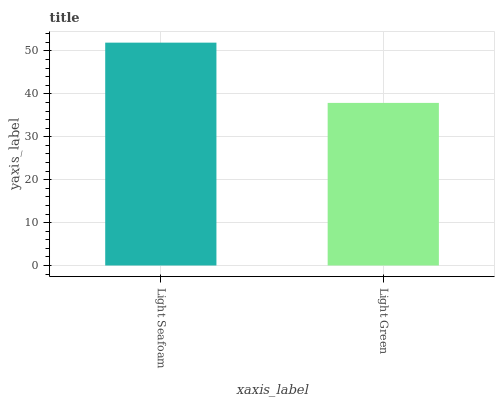Is Light Green the maximum?
Answer yes or no. No. Is Light Seafoam greater than Light Green?
Answer yes or no. Yes. Is Light Green less than Light Seafoam?
Answer yes or no. Yes. Is Light Green greater than Light Seafoam?
Answer yes or no. No. Is Light Seafoam less than Light Green?
Answer yes or no. No. Is Light Seafoam the high median?
Answer yes or no. Yes. Is Light Green the low median?
Answer yes or no. Yes. Is Light Green the high median?
Answer yes or no. No. Is Light Seafoam the low median?
Answer yes or no. No. 